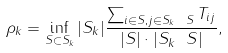Convert formula to latex. <formula><loc_0><loc_0><loc_500><loc_500>\rho _ { k } = \inf _ { S \subset S _ { k } } | S _ { k } | \frac { \sum _ { i \in S , j \in S _ { k } \ S } T _ { i j } } { | S | \cdot | S _ { k } \ S | } ,</formula> 